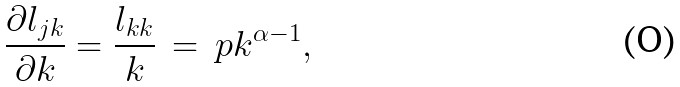Convert formula to latex. <formula><loc_0><loc_0><loc_500><loc_500>\frac { \partial l _ { j k } } { \partial k } = \frac { l _ { k k } } { k } \, = \, p k ^ { \alpha - 1 } ,</formula> 